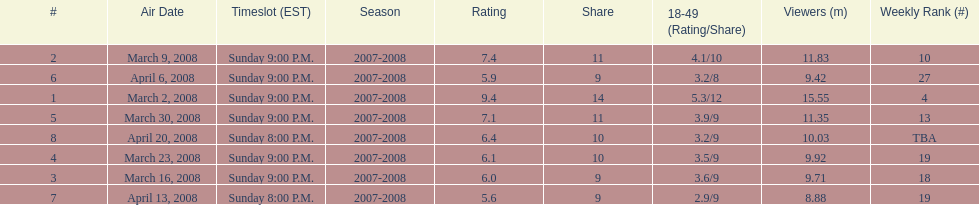Which show had the highest rating? 1. 